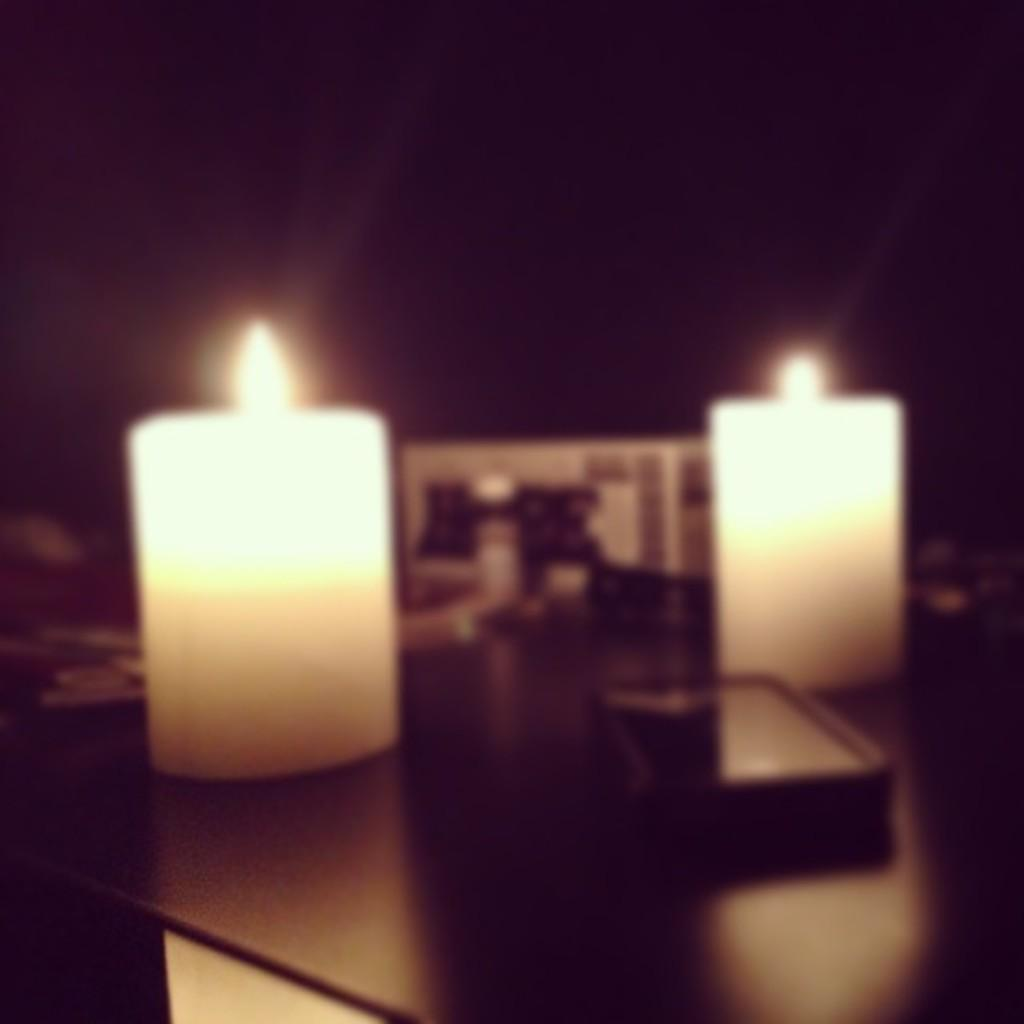How many candles are visible in the image? There are 2 candles in the image. What is the color of the table on which the candles are placed? The table is black. What can be seen on the table besides the candles? There are other things kept on the black table in the image. What is the lighting condition in the image? The background of the image is dark. What is the relationship between the mother and daughter in the image? There is no mother or daughter present in the image; it only features 2 candles on a black table with a dark background. 